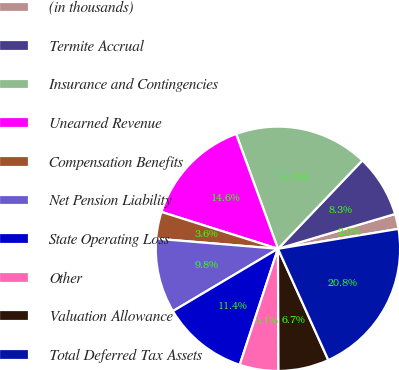Convert chart. <chart><loc_0><loc_0><loc_500><loc_500><pie_chart><fcel>(in thousands)<fcel>Termite Accrual<fcel>Insurance and Contingencies<fcel>Unearned Revenue<fcel>Compensation Benefits<fcel>Net Pension Liability<fcel>State Operating Loss<fcel>Other<fcel>Valuation Allowance<fcel>Total Deferred Tax Assets<nl><fcel>1.99%<fcel>8.27%<fcel>17.7%<fcel>14.56%<fcel>3.56%<fcel>9.84%<fcel>11.41%<fcel>5.13%<fcel>6.7%<fcel>20.84%<nl></chart> 